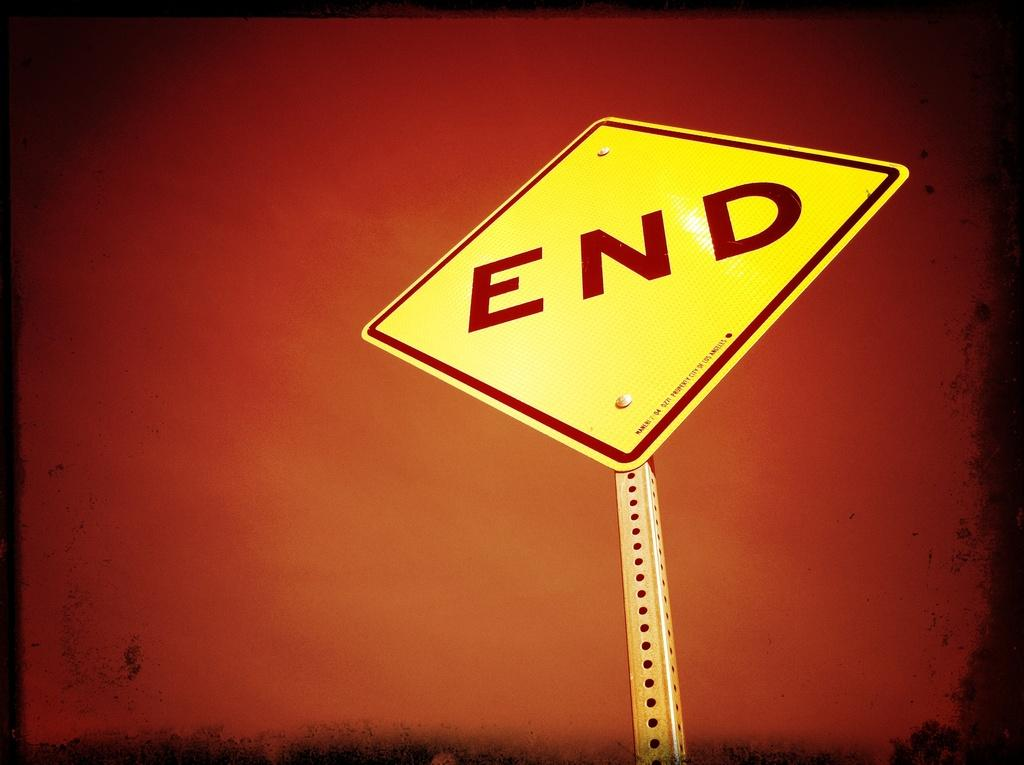<image>
Offer a succinct explanation of the picture presented. According to the sign this is the end. 